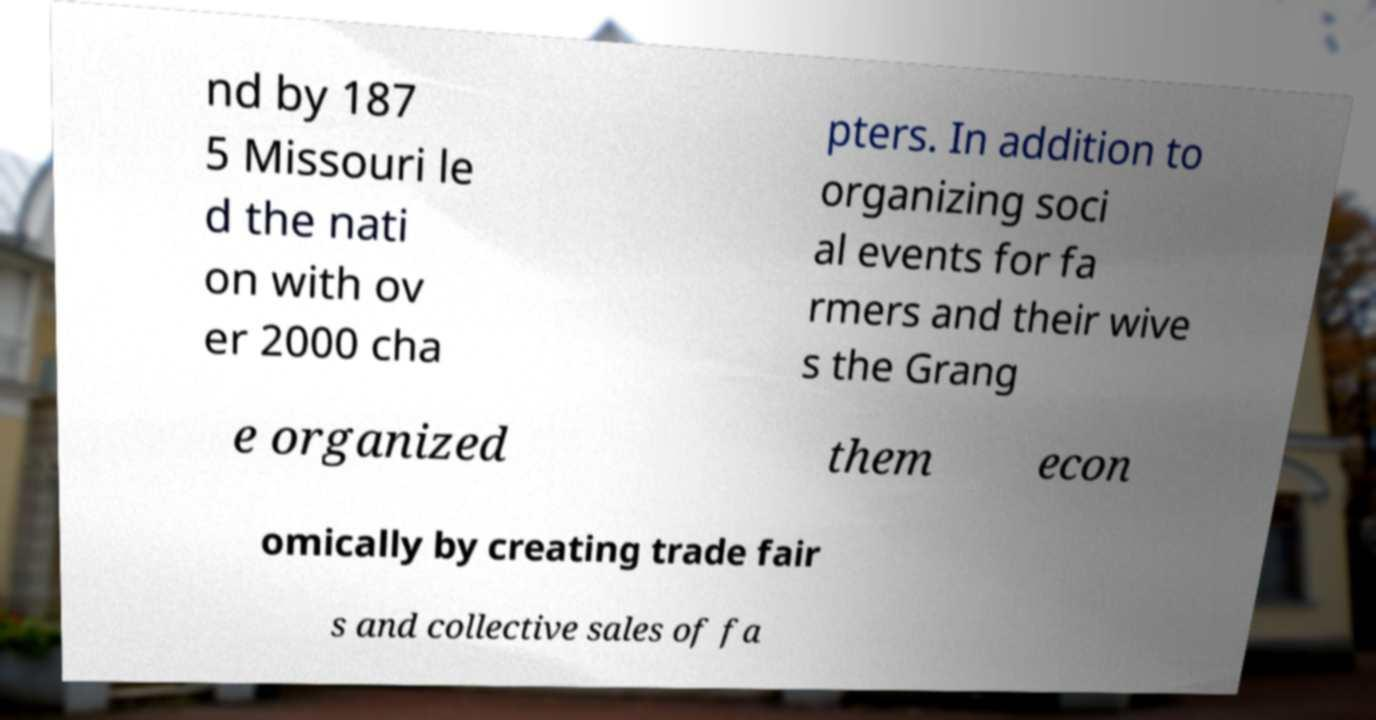What messages or text are displayed in this image? I need them in a readable, typed format. nd by 187 5 Missouri le d the nati on with ov er 2000 cha pters. In addition to organizing soci al events for fa rmers and their wive s the Grang e organized them econ omically by creating trade fair s and collective sales of fa 